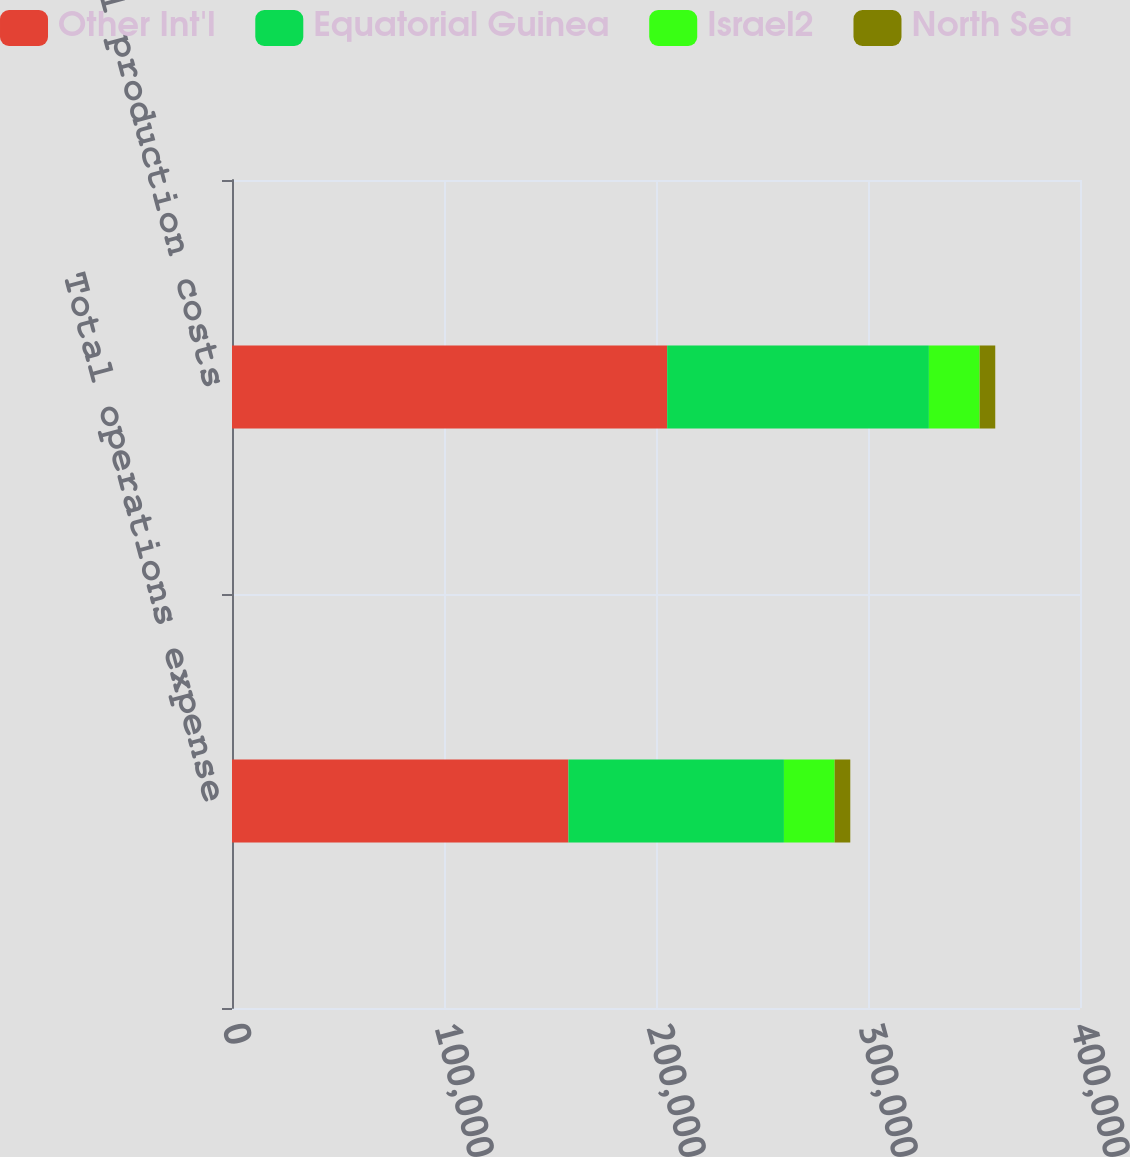Convert chart to OTSL. <chart><loc_0><loc_0><loc_500><loc_500><stacked_bar_chart><ecel><fcel>Total operations expense<fcel>Total production costs<nl><fcel>Other Int'l<fcel>158695<fcel>205270<nl><fcel>Equatorial Guinea<fcel>101648<fcel>123454<nl><fcel>Israel2<fcel>23936<fcel>23936<nl><fcel>North Sea<fcel>7366<fcel>7366<nl></chart> 